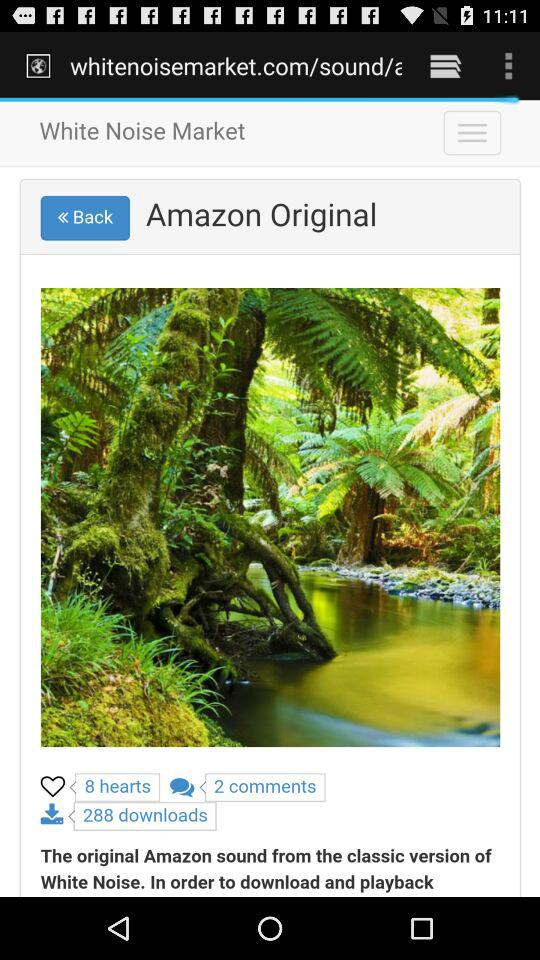How many more hearts does the sound have than comments?
Answer the question using a single word or phrase. 6 